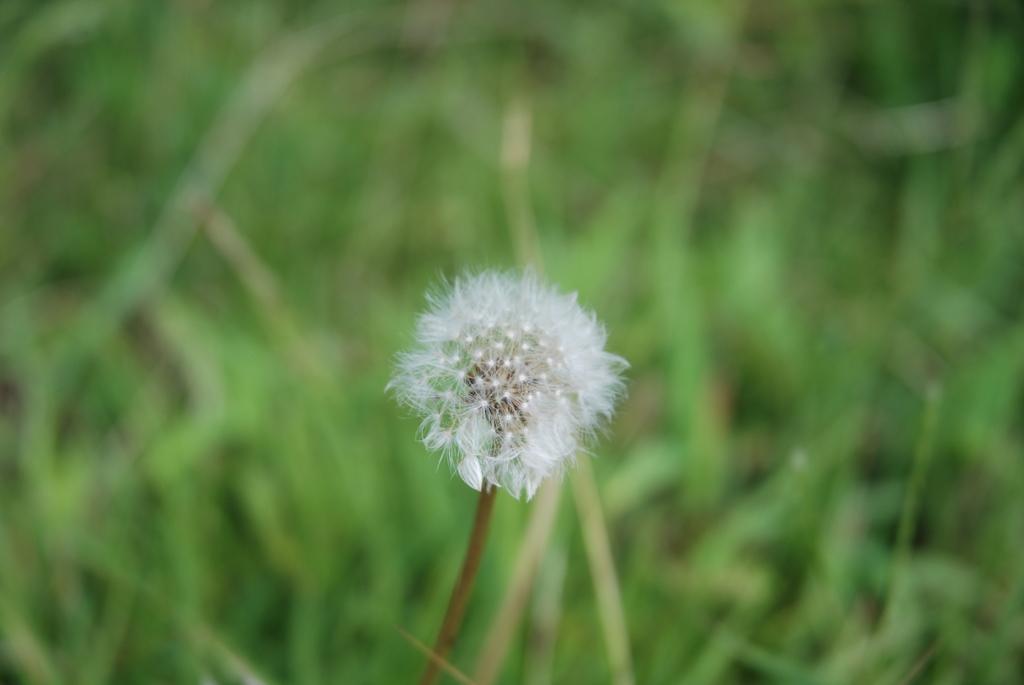Can you describe this image briefly? In this picture we can see a flower and in the background we can see leaves and it is blurry. 